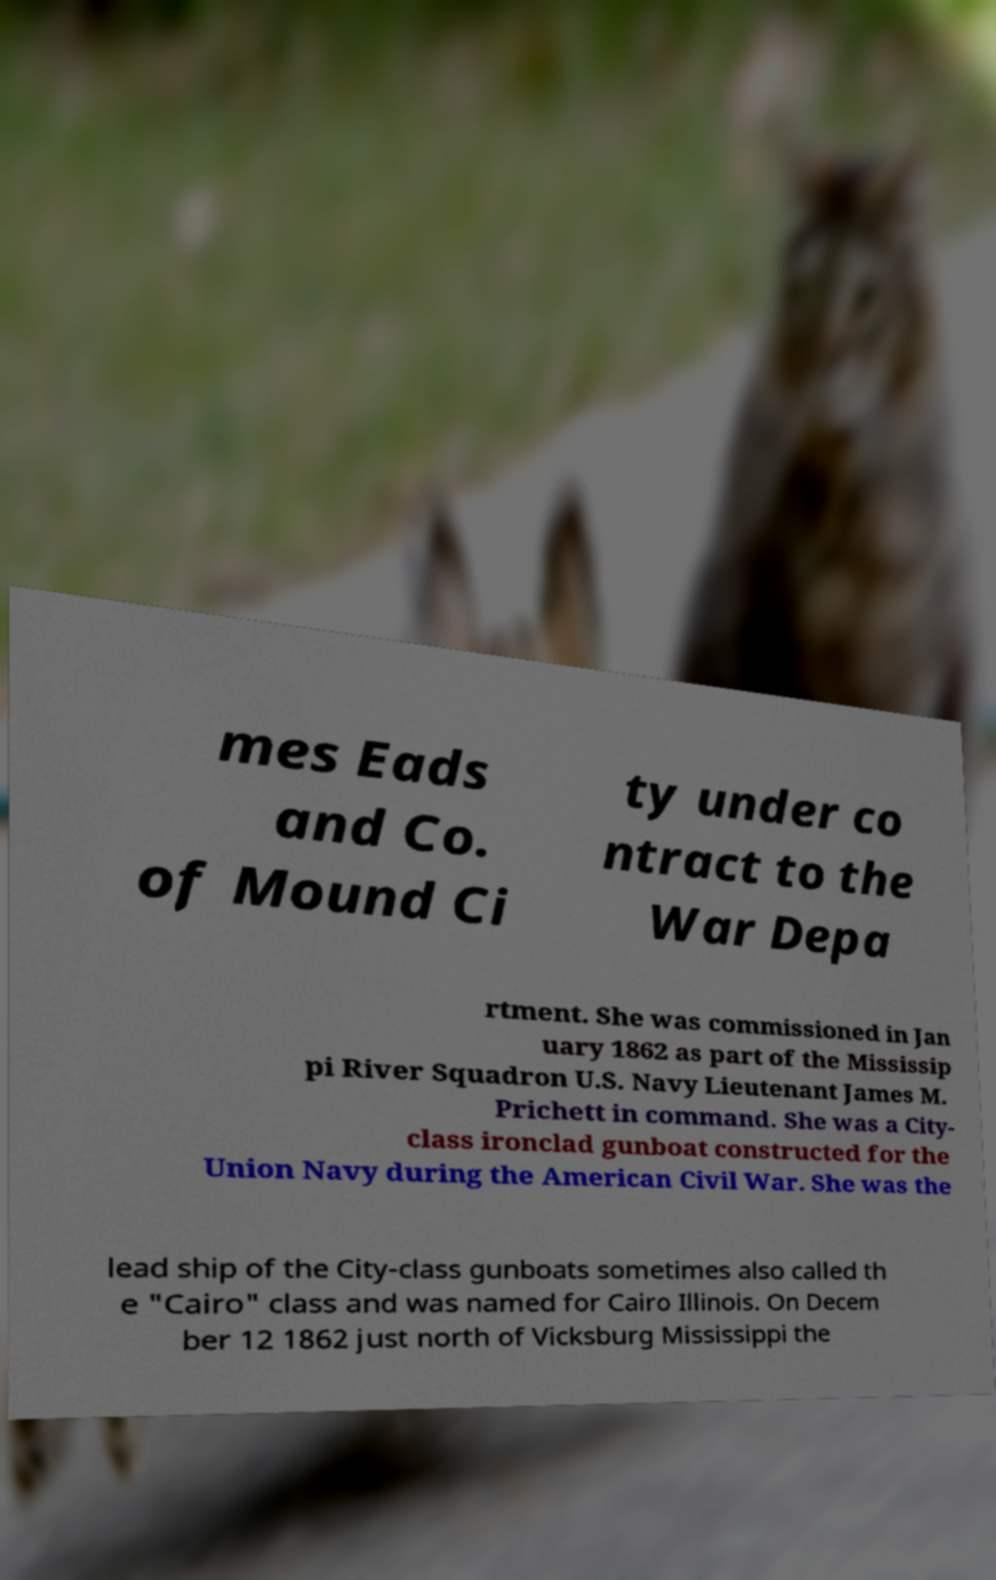What messages or text are displayed in this image? I need them in a readable, typed format. mes Eads and Co. of Mound Ci ty under co ntract to the War Depa rtment. She was commissioned in Jan uary 1862 as part of the Mississip pi River Squadron U.S. Navy Lieutenant James M. Prichett in command. She was a City- class ironclad gunboat constructed for the Union Navy during the American Civil War. She was the lead ship of the City-class gunboats sometimes also called th e "Cairo" class and was named for Cairo Illinois. On Decem ber 12 1862 just north of Vicksburg Mississippi the 